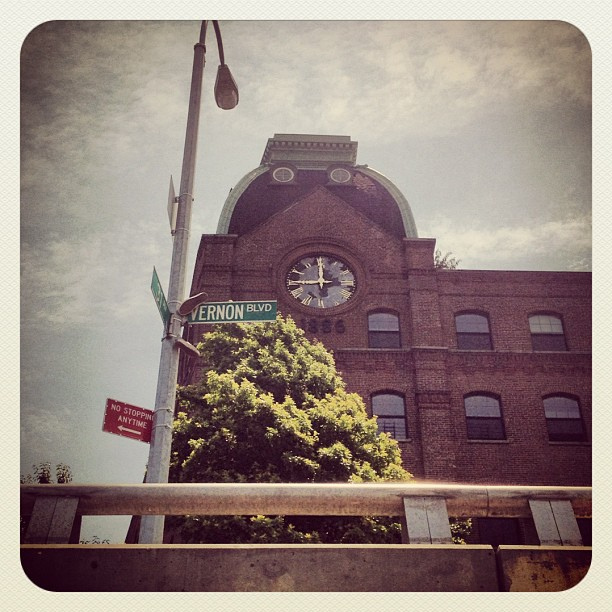It looks like a sunny day; can you describe how the weather seems to affect the scene? The bright sunlight enhances the building's red brick facade and casts gentle shadows, giving the scene a warm and pleasant feeling. It also illuminates the tree in the foreground, bringing out the greenery against the urban backdrop. 